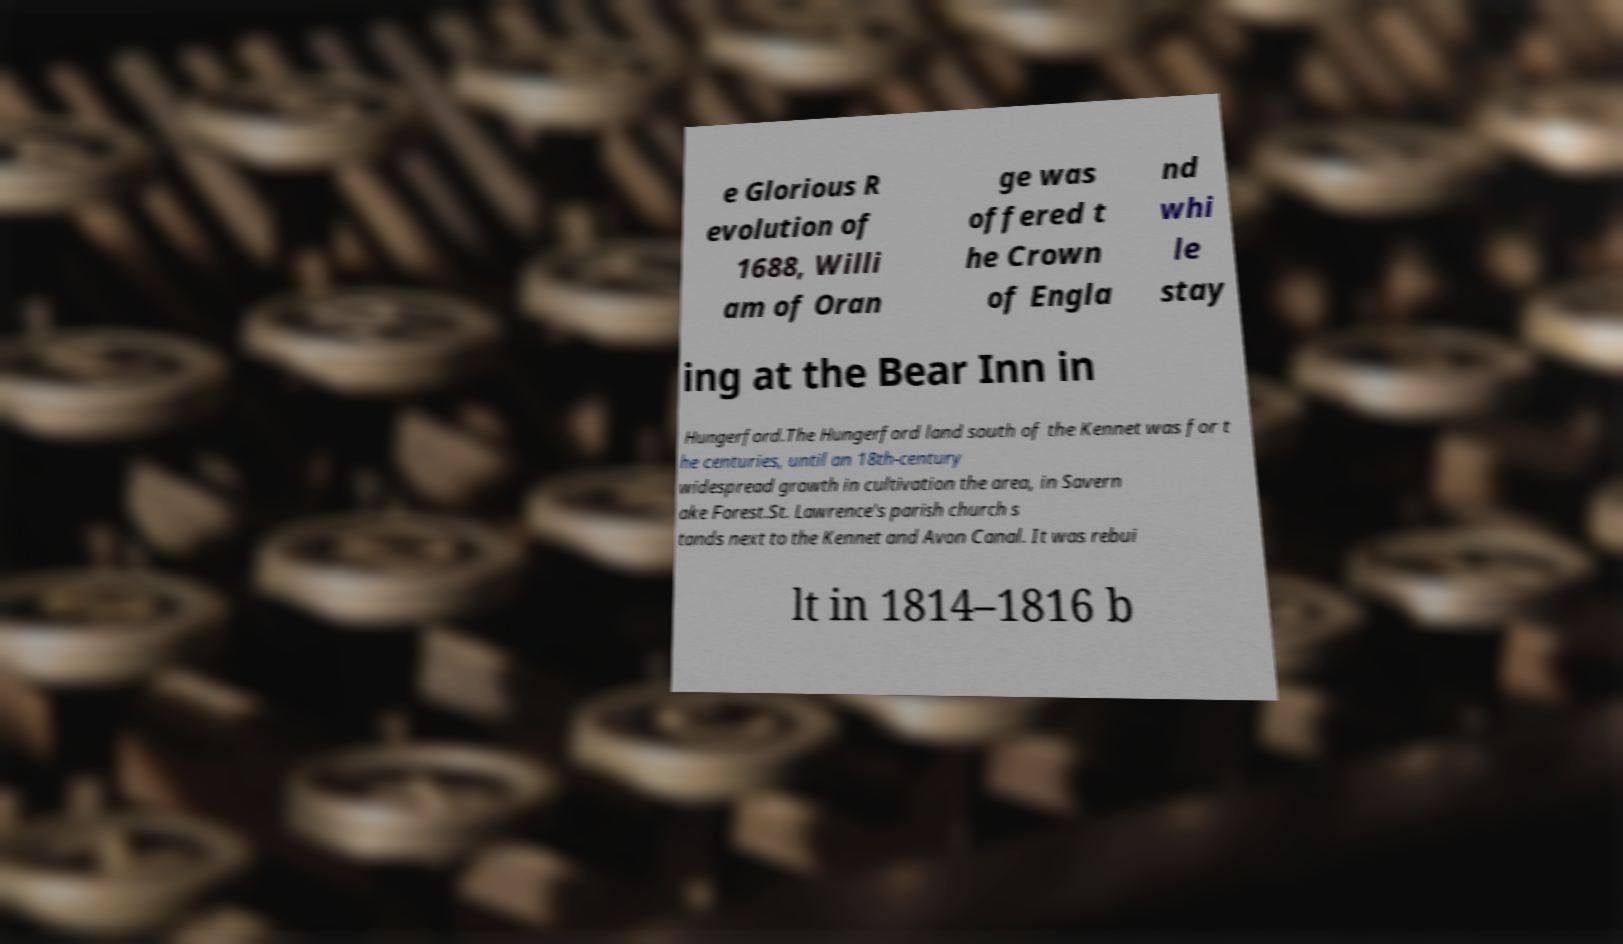Can you read and provide the text displayed in the image?This photo seems to have some interesting text. Can you extract and type it out for me? e Glorious R evolution of 1688, Willi am of Oran ge was offered t he Crown of Engla nd whi le stay ing at the Bear Inn in Hungerford.The Hungerford land south of the Kennet was for t he centuries, until an 18th-century widespread growth in cultivation the area, in Savern ake Forest.St. Lawrence's parish church s tands next to the Kennet and Avon Canal. It was rebui lt in 1814–1816 b 